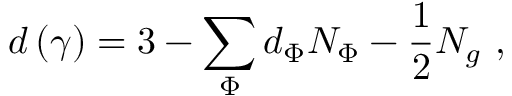Convert formula to latex. <formula><loc_0><loc_0><loc_500><loc_500>d \left ( \gamma \right ) = 3 - \sum _ { \Phi } d _ { \Phi } N _ { \Phi } - \frac { 1 } { 2 } N _ { g } \, ,</formula> 